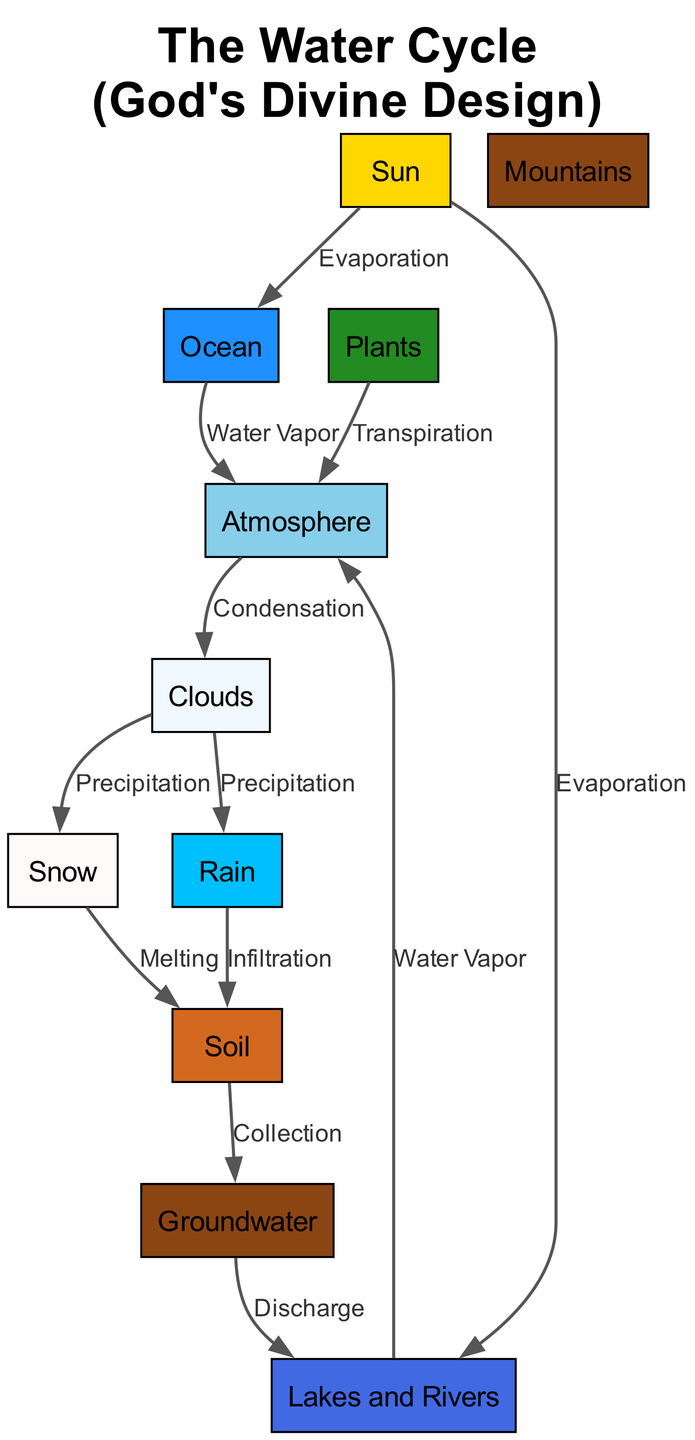What process does the Sun initiate in the water cycle? The diagram labels the process that the Sun initiates as "Evaporation," which connects the Sun to both the Ocean and Lakes and Rivers. This shows that the Sun provides the energy needed for water to transition from a liquid state to a gaseous state, starting the cycle.
Answer: Evaporation How many types of precipitation are shown in the diagram? According to the diagram, there are two types of precipitation indicated: Rain and Snow. These are directly linked to the Clouds as outcomes of the atmospheric processes.
Answer: Two What is the final destination of rainwater in the water cycle? The diagram indicates that rainwater, after falling, infiltrates into the Soil and subsequently contributes to the Groundwater. Thus, the final destination of rainwater is the Groundwater where it is stored underground.
Answer: Groundwater Which elements contribute to evaporation in the diagram? The diagram shows that both the Ocean and Lakes and Rivers are involved in the evaporation process, as they receive energy from the Sun, which drives the transition of water into vapor.
Answer: Ocean and Lakes and Rivers What happens to the water vapor in the Atmosphere? The diagram states that the water vapor in the Atmosphere goes through a process called "Condensation," which results in the formation of Clouds. This explains how water vapor transitions back into a liquid state.
Answer: Condensation Which natural feature is associated with orographic precipitation? The diagram indicates that Mountains are associated with orographic precipitation. This implies that elevated terrains can cause precipitation patterns due to the presence of moisture-laden air moving upward.
Answer: Mountains What process leads to the transformation of Clouds into Rain? The diagram shows that Clouds produce Rain through the process of "Precipitation." This is the direct transition from the cloud formation to liquid precipitation.
Answer: Precipitation How does groundwater recharge occur in the water cycle? According to the diagram, groundwater recharge occurs through the "Collection" process in the Soil after rainwater infiltrates. The flow from the Soil into the Groundwater represents this recharge mechanism.
Answer: Collection How does transpiration contribute to the water cycle? The diagram indicates that Plants contribute water to the Atmosphere through the process of "Transpiration." This means that as plants release water vapor into the air, they play an important role in the water cycle.
Answer: Transpiration 